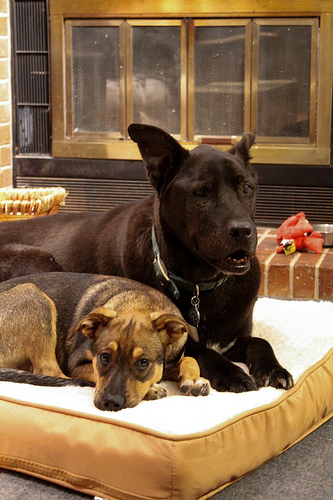<image>
Is there a leash on the dog? Yes. Looking at the image, I can see the leash is positioned on top of the dog, with the dog providing support. Where is the dog in relation to the dog? Is it under the dog? No. The dog is not positioned under the dog. The vertical relationship between these objects is different. Is there a dog under the dog bed? No. The dog is not positioned under the dog bed. The vertical relationship between these objects is different. Where is the dog in relation to the dog? Is it in front of the dog? No. The dog is not in front of the dog. The spatial positioning shows a different relationship between these objects. 